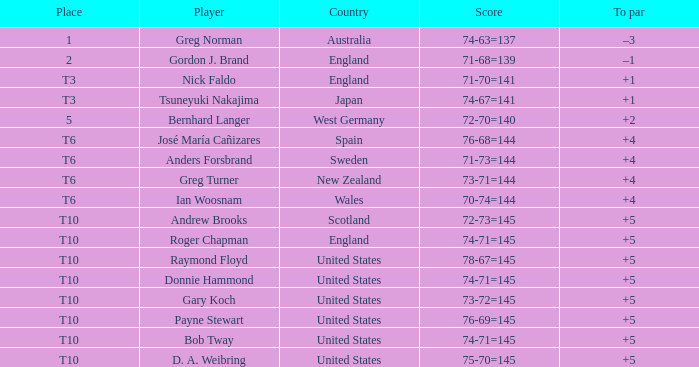What was Anders Forsbrand's score when the TO par is +4? 71-73=144. 